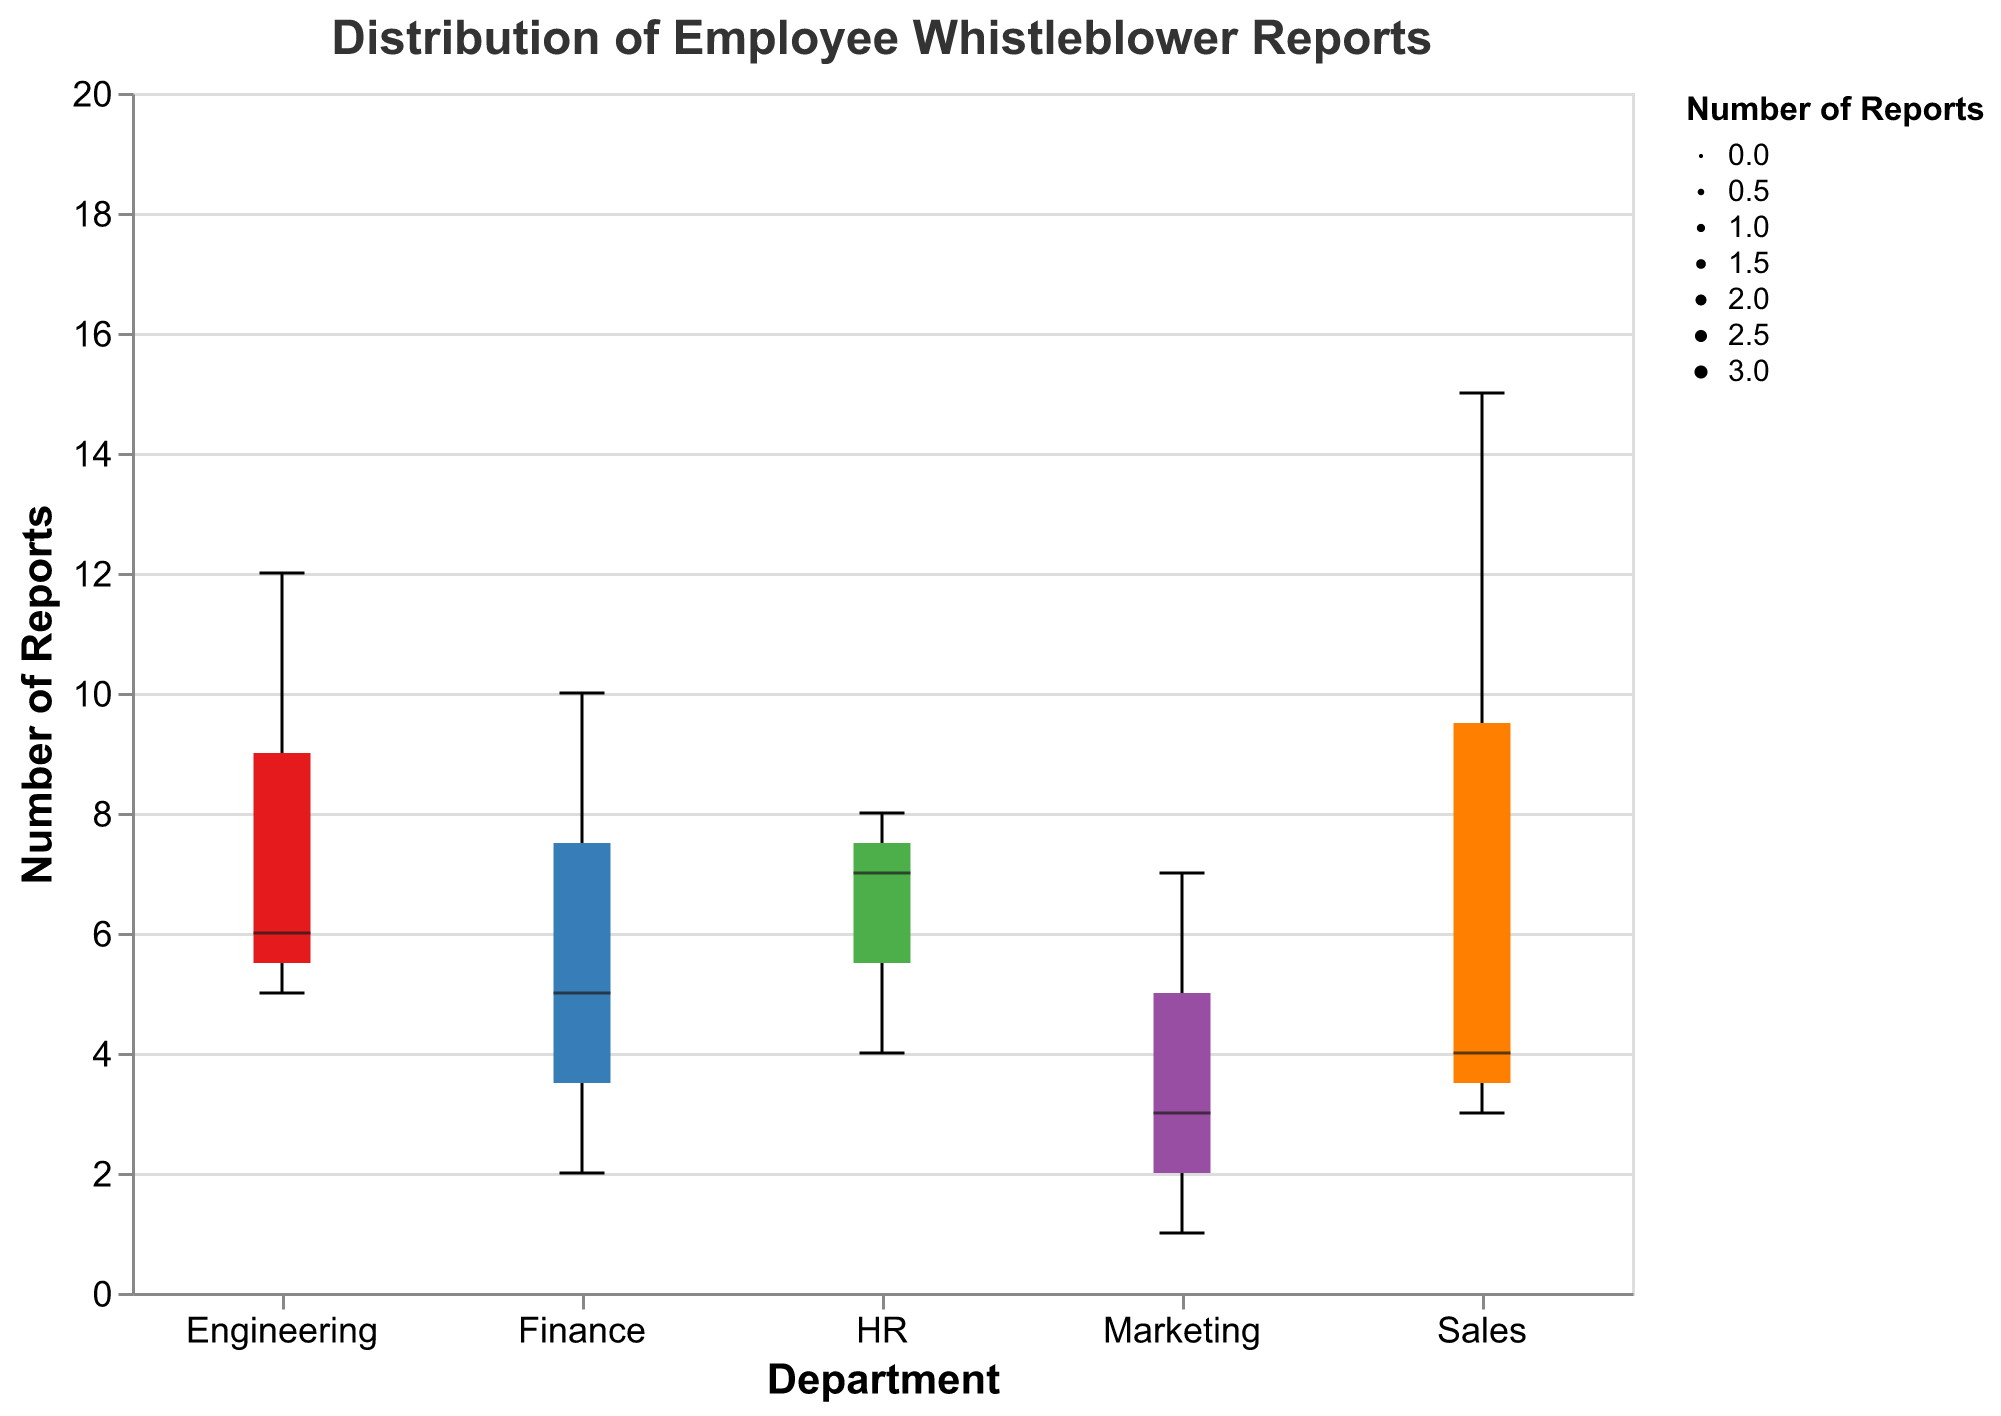Which department has the highest number of low severity whistleblower reports? The figure shows the number of low-severity reports for each department. By examining the height of the low-severity box for each department, Sales has the highest count.
Answer: Sales What's the median value of high severity reports across all departments? The figure visualizes the median values as central lines within each boxplot for high severity reports. Comparing these lines for all departments, the median appears to be consistent among departments having high severity counts around the middle value.
Answer: 3 Which department has the most varied distribution of whistleblower report severity levels? To find the department with the most varied distribution, look at the spread of the boxplots. Engineering has the widest spread from the low to high severity levels, indicating the most variation in report severity.
Answer: Engineering How many total whistleblower reports are there for the HR department? By summing the counts for HR in the three severity levels (Low: 8, Moderate: 7, High: 4), the total number of reports is 8 + 7 + 4 = 19.
Answer: 19 Which two departments have the smallest number of high-severity whistleblower reports? Looking at the high severity sections of the box plots for all departments, Marketing and Finance have the smallest, with counts 1 and 2 respectively.
Answer: Marketing and Finance What is the total count of whistleblower reports with moderate severity? Summing the moderate severity counts across all departments (Finance: 5, Sales: 4, HR: 7, Engineering: 6, Marketing: 3) gives 5 + 4 + 7 + 6 + 3 = 25.
Answer: 25 How does the count of high severity reports in Engineering compare to those in Sales? The boxplot shows Engineering has a slightly higher number of high severity reports (5) compared to Sales (3).
Answer: Engineering has more Which department has the smallest total number of whistleblower reports? By summing the counts across all severity levels for each department and comparing, Marketing has the smallest total (Low: 7, Moderate: 3, High: 1), which is 7 + 3 + 1 = 11.
Answer: Marketing What is the difference in the number of moderate severity reports between HR and Marketing? By subtracting Marketing's moderate severity reports (3) from HR's (7), the difference is 7 - 3 = 4.
Answer: 4 Which department’s distribution of reports shows the narrowest range? Looking at the overall spread of the boxplots, Finance shows the narrowest range from low to high severity reports.
Answer: Finance 